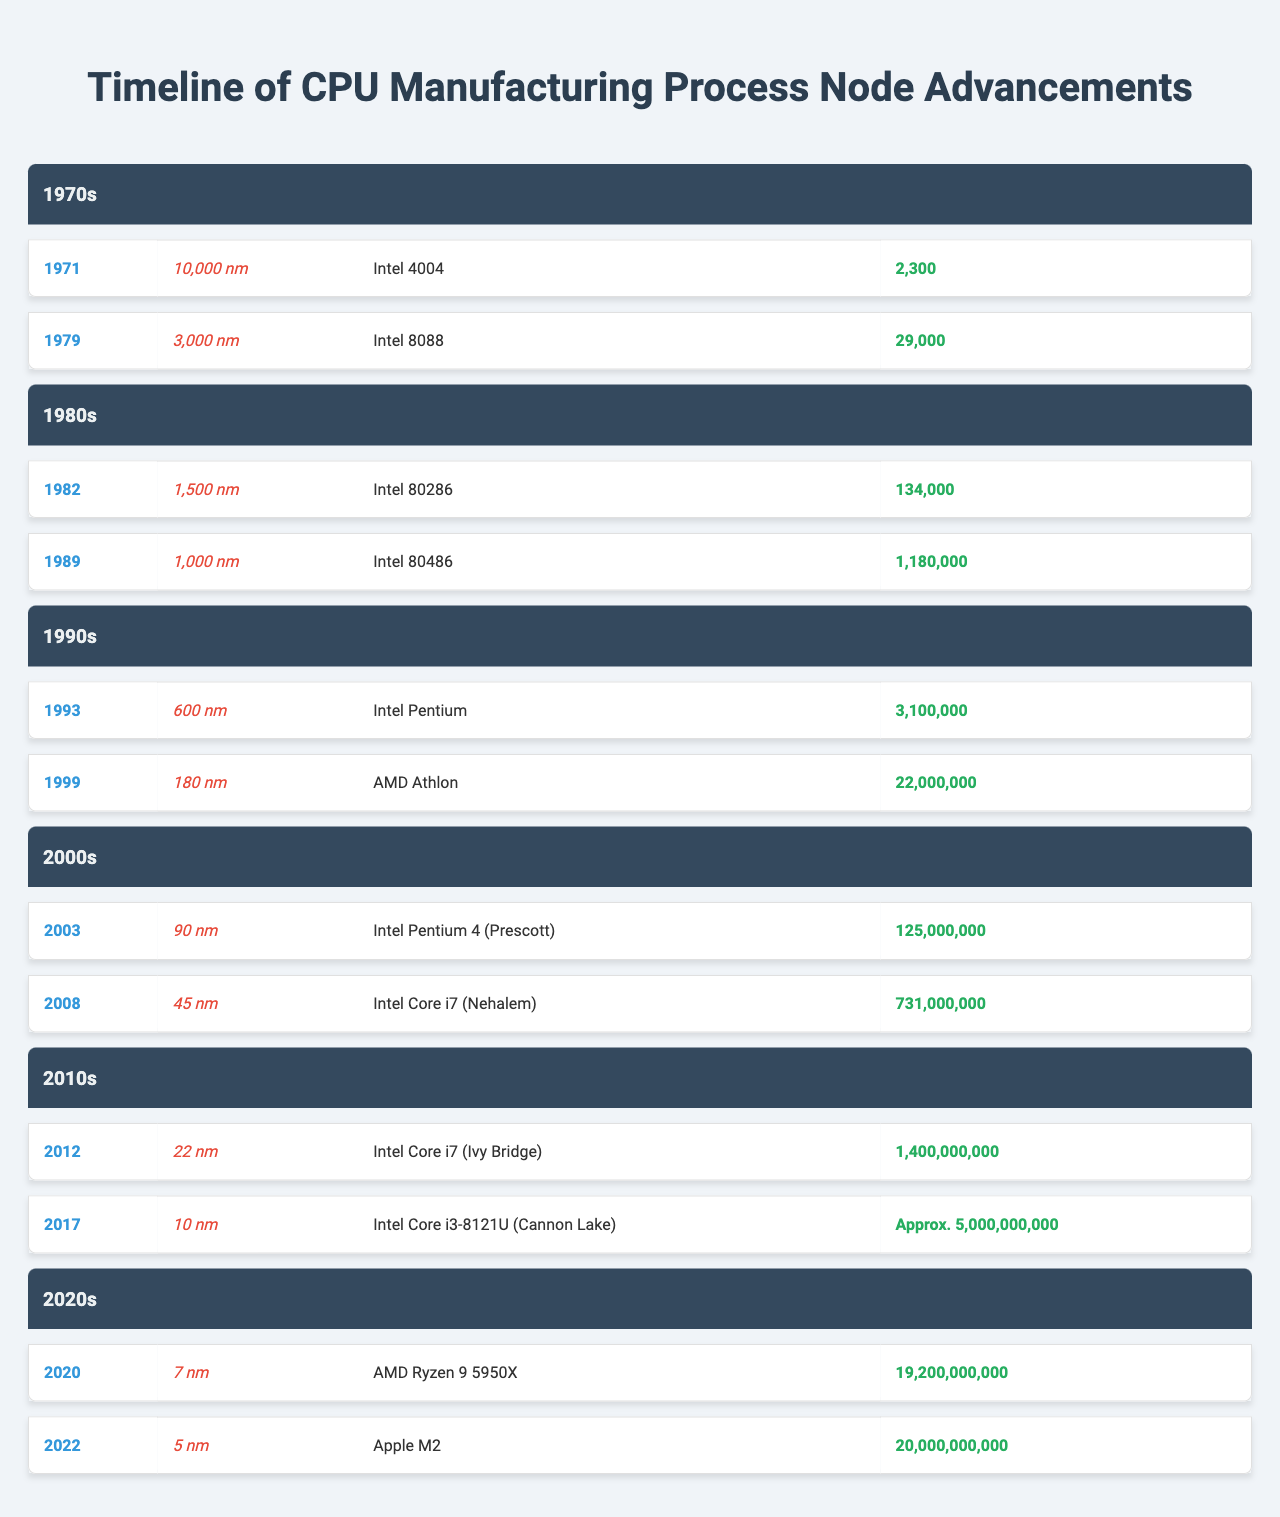What was the first CPU released with a 10,000 nm process node? The table indicates that the first CPU with a 10,000 nm process node was the Intel 4004, which was released in 1971.
Answer: Intel 4004 In which year was the Intel Core i7 released? According to the table, the Intel Core i7 was released in 2008.
Answer: 2008 Which CPU from the 1990s had the highest transistor count? The AMD Athlon, released in 1999, had a transistor count of 22,000,000, which is higher than the Intel Pentium released in 1993 with 3,100,000 transistors.
Answer: AMD Athlon What is the average process node size for CPUs released in the 2000s? The two process nodes in the 2000s are 90 nm and 45 nm. The average is calculated by (90 + 45) / 2 = 67.5 nm.
Answer: 67.5 nm How many transistors does the Intel Core i3-8121U (Cannon Lake) approximately have? The table lists that the Intel Core i3-8121U (Cannon Lake) has approximately 5,000,000,000 transistors.
Answer: Approx. 5,000,000,000 True or False: The Intel 80286 was released in the 1970s. The table shows that the Intel 80286 was released in 1982, which is not in the 1970s, making this statement false.
Answer: False What is the trend in transistor counts from the 1970s to the 2020s? Observing the data from the table, there is a clear increasing trend in transistor counts from 2,300 in the 1970s to 20,000,000,000 in the 2020s, demonstrating significant growth.
Answer: Increasing trend Which era had the first CPU with a process node smaller than 100 nm? The 2000s era had the first CPU with a process node smaller than 100 nm, specifically the Intel Core i7 (Nehalem) in 2008 at 45 nm.
Answer: 2000s If we sum the transistor counts of all CPUs listed in the 1990s, what is the total transistor count? The total transistor count for the 1990s CPUs listed in the table sums up as follows: 3,100,000 (Intel Pentium) + 22,000,000 (AMD Athlon) = 25,100,000.
Answer: 25,100,000 Which CPU had the smallest process node size in the 2010s? The table indicates that the Intel Core i3-8121U (Cannon Lake) had the smallest process node size of 10 nm in the 2010s.
Answer: Intel Core i3-8121U (Cannon Lake) 